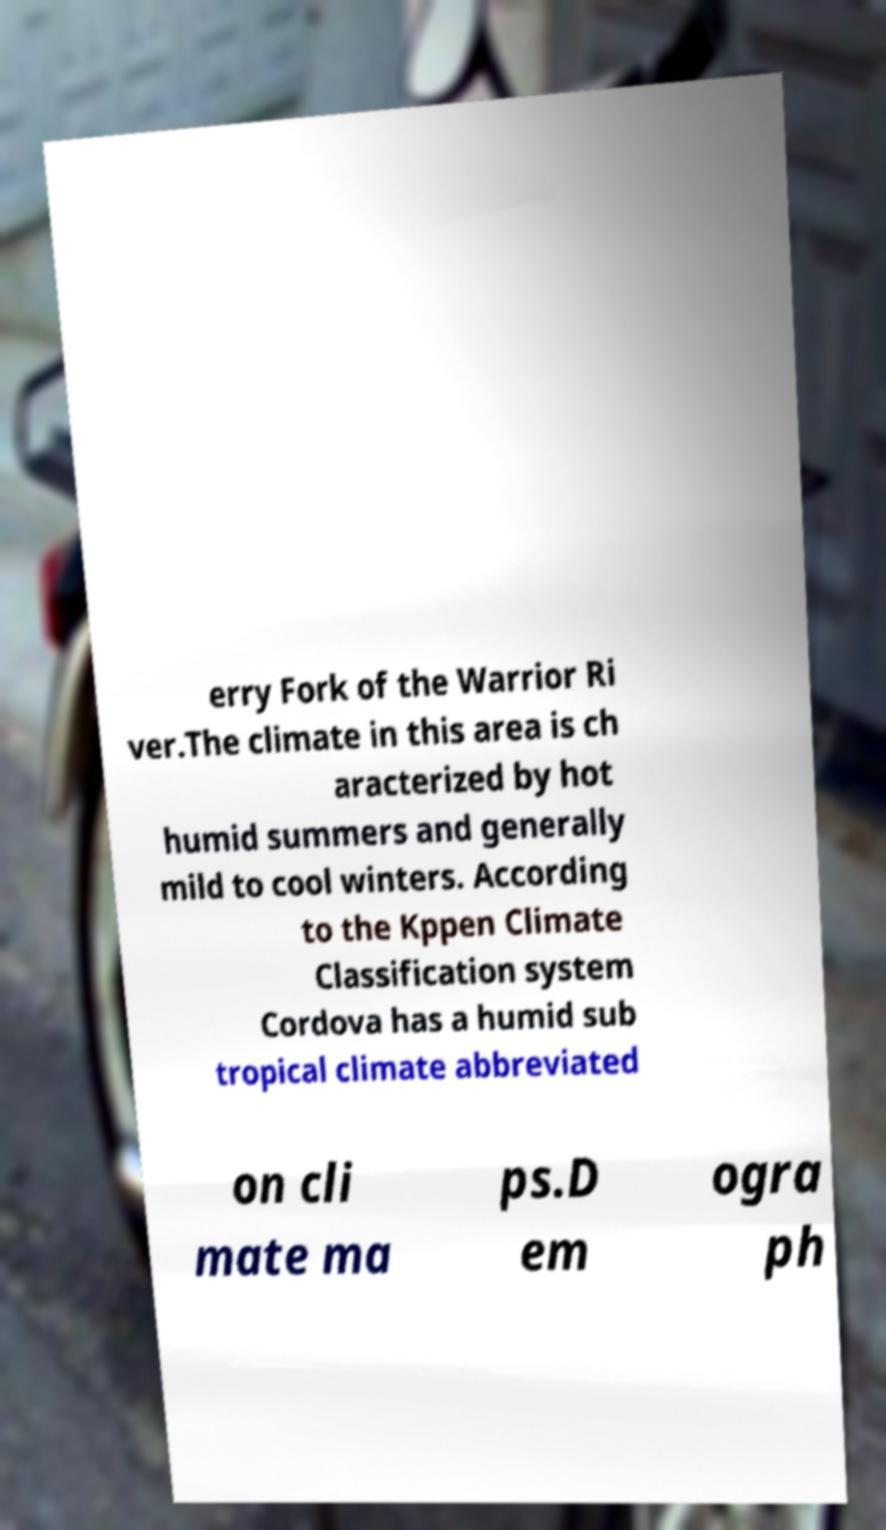For documentation purposes, I need the text within this image transcribed. Could you provide that? erry Fork of the Warrior Ri ver.The climate in this area is ch aracterized by hot humid summers and generally mild to cool winters. According to the Kppen Climate Classification system Cordova has a humid sub tropical climate abbreviated on cli mate ma ps.D em ogra ph 